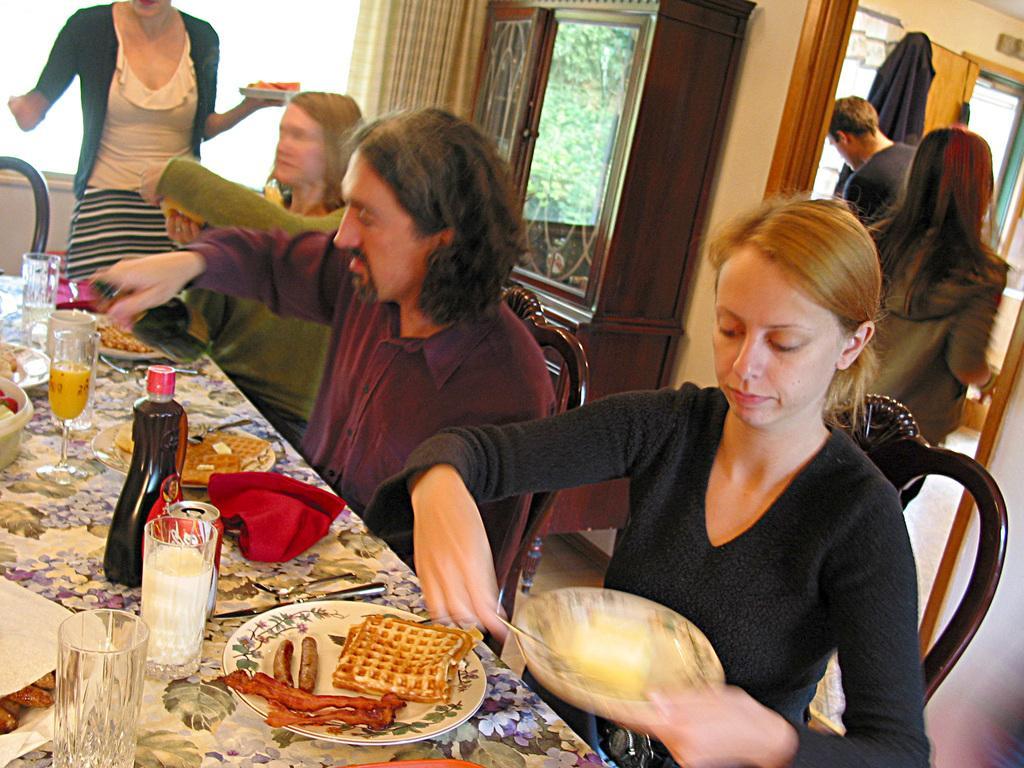How would you summarize this image in a sentence or two? In this image there are group of persons who are sitting and having their food and at the left side of the image there are glasses,bottles and plates on the table and at the right side of the image there are two persons standing. 